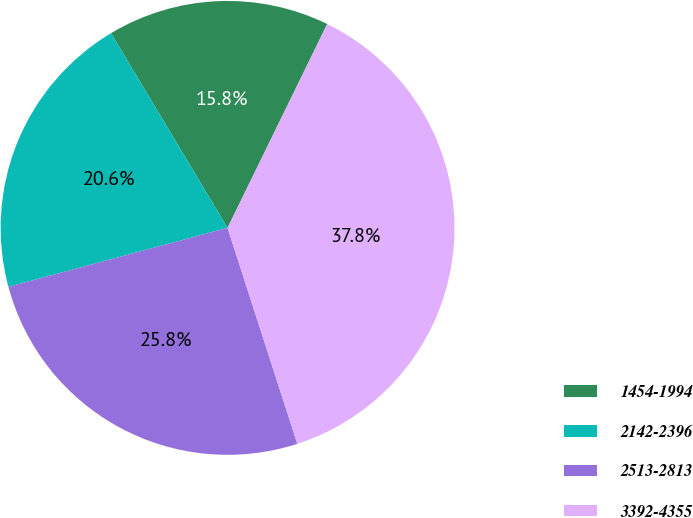<chart> <loc_0><loc_0><loc_500><loc_500><pie_chart><fcel>1454-1994<fcel>2142-2396<fcel>2513-2813<fcel>3392-4355<nl><fcel>15.82%<fcel>20.6%<fcel>25.79%<fcel>37.79%<nl></chart> 